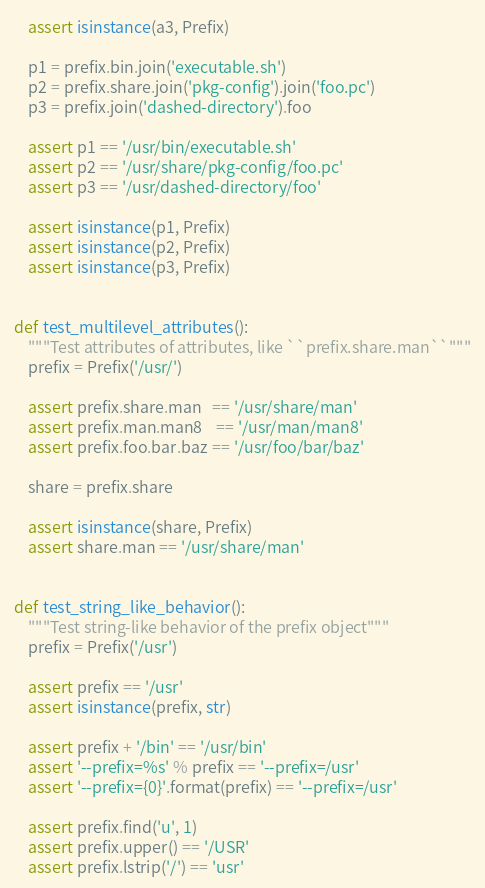Convert code to text. <code><loc_0><loc_0><loc_500><loc_500><_Python_>    assert isinstance(a3, Prefix)

    p1 = prefix.bin.join('executable.sh')
    p2 = prefix.share.join('pkg-config').join('foo.pc')
    p3 = prefix.join('dashed-directory').foo

    assert p1 == '/usr/bin/executable.sh'
    assert p2 == '/usr/share/pkg-config/foo.pc'
    assert p3 == '/usr/dashed-directory/foo'

    assert isinstance(p1, Prefix)
    assert isinstance(p2, Prefix)
    assert isinstance(p3, Prefix)


def test_multilevel_attributes():
    """Test attributes of attributes, like ``prefix.share.man``"""
    prefix = Prefix('/usr/')

    assert prefix.share.man   == '/usr/share/man'
    assert prefix.man.man8    == '/usr/man/man8'
    assert prefix.foo.bar.baz == '/usr/foo/bar/baz'

    share = prefix.share

    assert isinstance(share, Prefix)
    assert share.man == '/usr/share/man'


def test_string_like_behavior():
    """Test string-like behavior of the prefix object"""
    prefix = Prefix('/usr')

    assert prefix == '/usr'
    assert isinstance(prefix, str)

    assert prefix + '/bin' == '/usr/bin'
    assert '--prefix=%s' % prefix == '--prefix=/usr'
    assert '--prefix={0}'.format(prefix) == '--prefix=/usr'

    assert prefix.find('u', 1)
    assert prefix.upper() == '/USR'
    assert prefix.lstrip('/') == 'usr'
</code> 